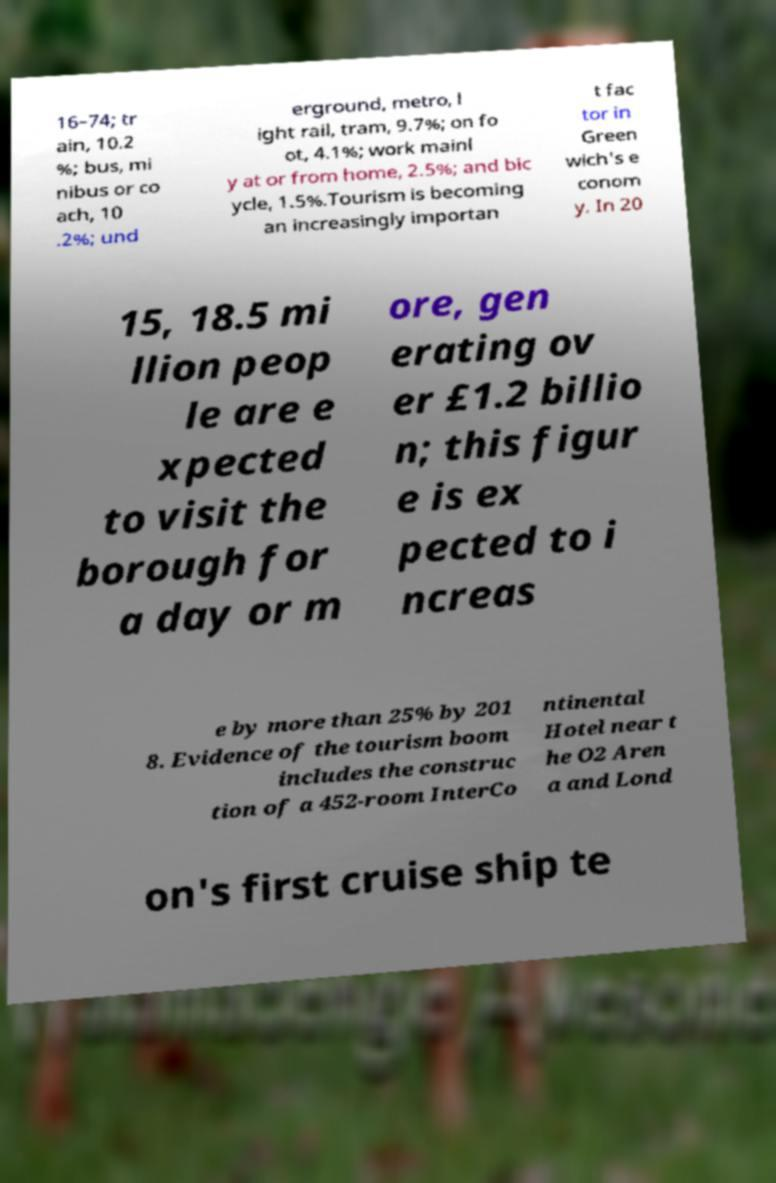Can you accurately transcribe the text from the provided image for me? 16–74; tr ain, 10.2 %; bus, mi nibus or co ach, 10 .2%; und erground, metro, l ight rail, tram, 9.7%; on fo ot, 4.1%; work mainl y at or from home, 2.5%; and bic ycle, 1.5%.Tourism is becoming an increasingly importan t fac tor in Green wich's e conom y. In 20 15, 18.5 mi llion peop le are e xpected to visit the borough for a day or m ore, gen erating ov er £1.2 billio n; this figur e is ex pected to i ncreas e by more than 25% by 201 8. Evidence of the tourism boom includes the construc tion of a 452-room InterCo ntinental Hotel near t he O2 Aren a and Lond on's first cruise ship te 